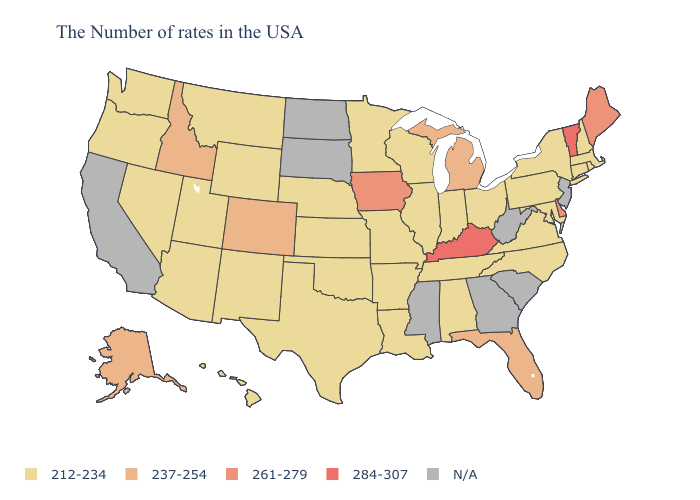Name the states that have a value in the range N/A?
Quick response, please. New Jersey, South Carolina, West Virginia, Georgia, Mississippi, South Dakota, North Dakota, California. What is the lowest value in the Northeast?
Short answer required. 212-234. Does the map have missing data?
Short answer required. Yes. Among the states that border Oregon , which have the highest value?
Concise answer only. Idaho. Is the legend a continuous bar?
Write a very short answer. No. What is the value of Arkansas?
Give a very brief answer. 212-234. Name the states that have a value in the range N/A?
Write a very short answer. New Jersey, South Carolina, West Virginia, Georgia, Mississippi, South Dakota, North Dakota, California. Name the states that have a value in the range N/A?
Keep it brief. New Jersey, South Carolina, West Virginia, Georgia, Mississippi, South Dakota, North Dakota, California. What is the value of Wyoming?
Be succinct. 212-234. What is the lowest value in the Northeast?
Answer briefly. 212-234. What is the value of Montana?
Concise answer only. 212-234. What is the value of Oklahoma?
Give a very brief answer. 212-234. Name the states that have a value in the range N/A?
Concise answer only. New Jersey, South Carolina, West Virginia, Georgia, Mississippi, South Dakota, North Dakota, California. What is the value of Iowa?
Answer briefly. 261-279. Name the states that have a value in the range 212-234?
Give a very brief answer. Massachusetts, Rhode Island, New Hampshire, Connecticut, New York, Maryland, Pennsylvania, Virginia, North Carolina, Ohio, Indiana, Alabama, Tennessee, Wisconsin, Illinois, Louisiana, Missouri, Arkansas, Minnesota, Kansas, Nebraska, Oklahoma, Texas, Wyoming, New Mexico, Utah, Montana, Arizona, Nevada, Washington, Oregon, Hawaii. 